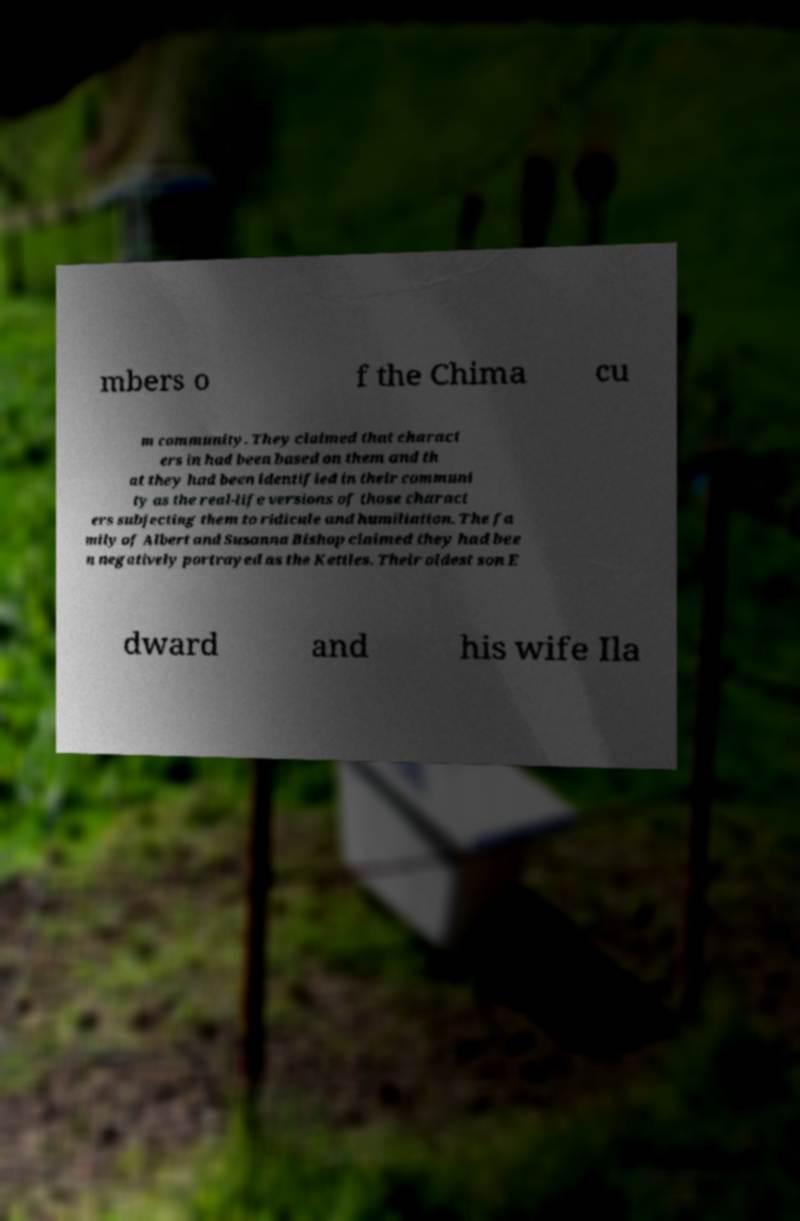Could you assist in decoding the text presented in this image and type it out clearly? mbers o f the Chima cu m community. They claimed that charact ers in had been based on them and th at they had been identified in their communi ty as the real-life versions of those charact ers subjecting them to ridicule and humiliation. The fa mily of Albert and Susanna Bishop claimed they had bee n negatively portrayed as the Kettles. Their oldest son E dward and his wife Ila 